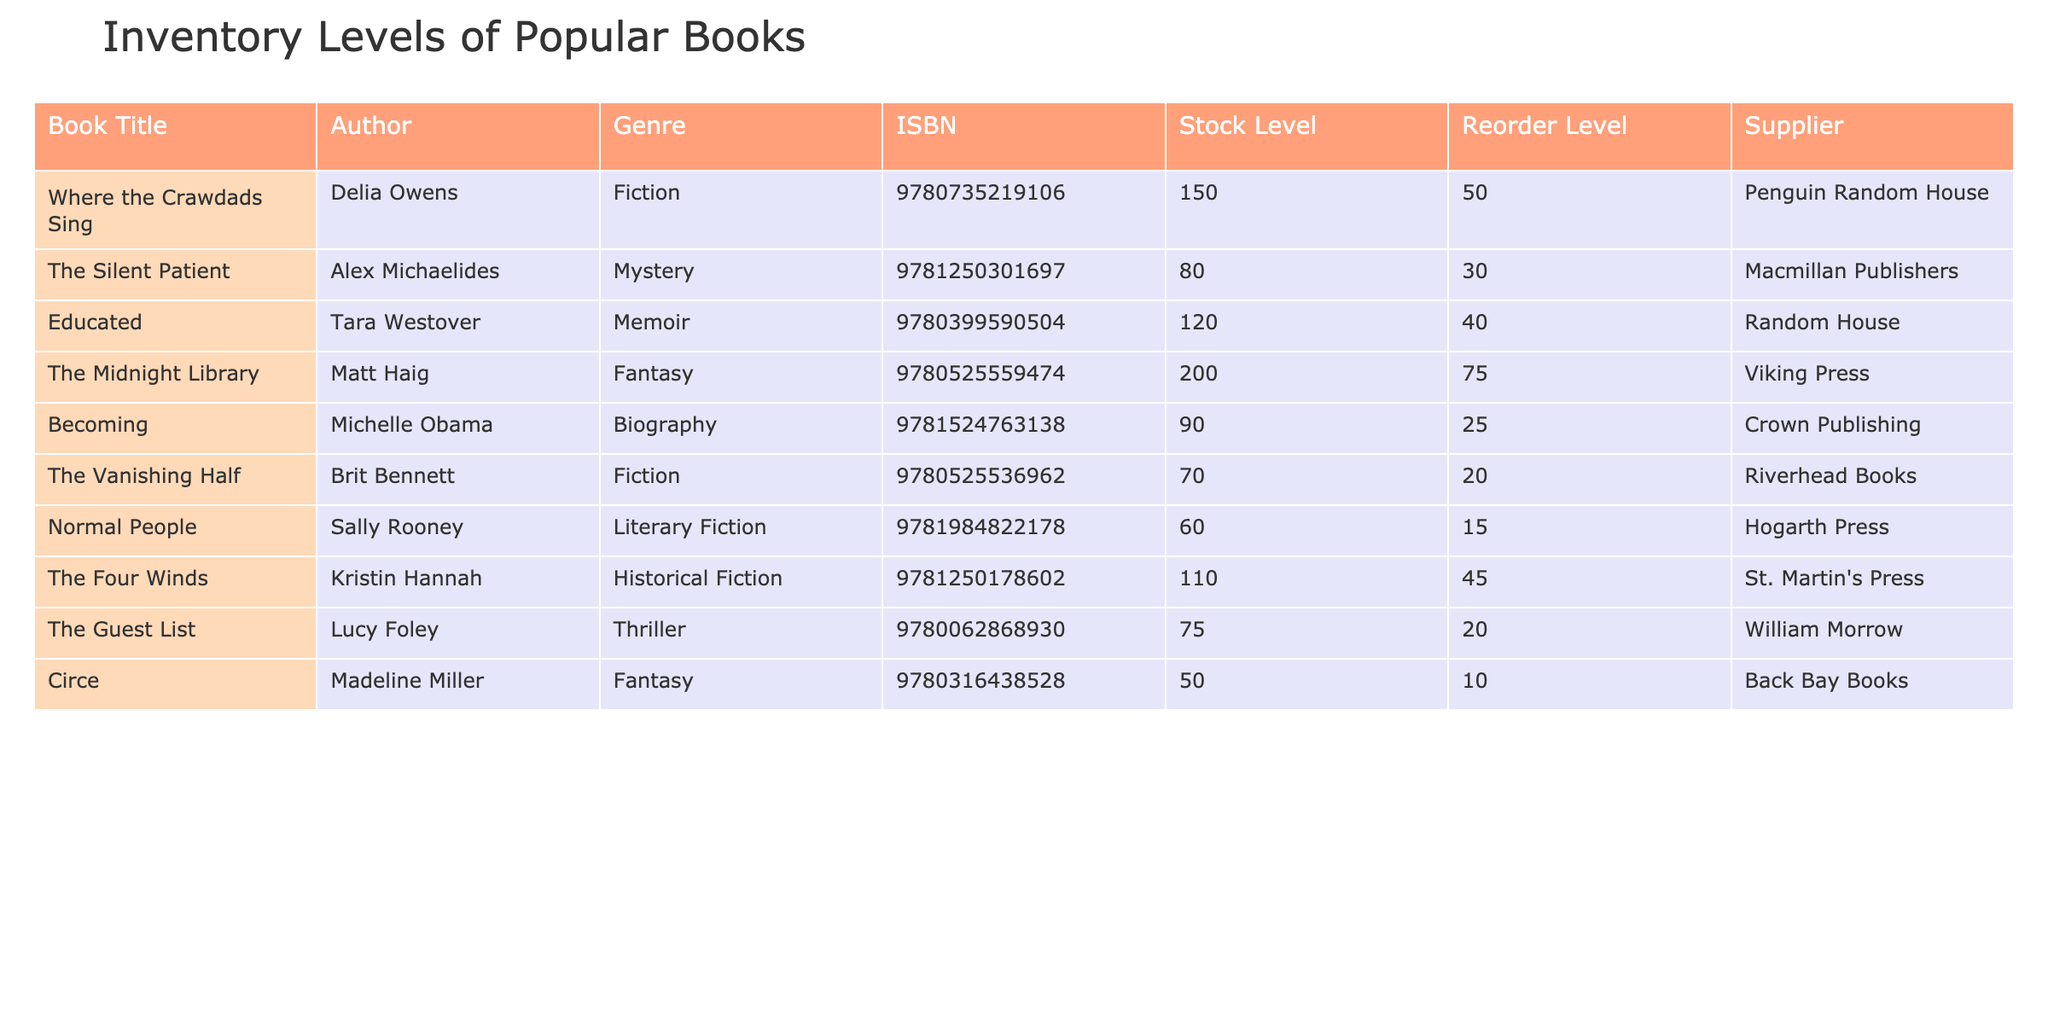What is the stock level of "The Silent Patient"? According to the table, the stock level of "The Silent Patient" is directly listed under the Stock Level column. Referring to the row associated with this book, we see the value is 80.
Answer: 80 Which book has the highest stock level? To determine which book has the highest stock level, we compare all stock levels listed. The values are 150, 80, 120, 200, 90, 70, 60, 110, 75, and 50. The maximum value is 200, corresponding to "The Midnight Library".
Answer: The Midnight Library Are there more than 100 copies of "Educated" in stock? The stock level of "Educated" is given as 120. Since 120 is greater than 100, we conclude that there are indeed more copies than 100.
Answer: Yes What is the average stock level of all books? First, we sum the stock levels: 150 + 80 + 120 + 200 + 90 + 70 + 60 + 110 + 75 + 50 = 1025. There are 10 books, so we divide 1025 by 10 to find the average, which is 102.5.
Answer: 102.5 Is the reorder level of "Circe" less than 15? The reorder level for "Circe" is listed as 10. Since 10 is less than 15, this statement is true.
Answer: Yes Which author has a book with a stock level below the reorder level? By reviewing the stock levels and their respective reorder levels, we identify "Normal People" by Sally Rooney with a stock level of 60 and reorder level of 15, and "The Vanishing Half" by Brit Bennett with a stock level of 70 and reorder level of 20. Both are above their reorder levels, but "Circe" by Madeline Miller has a stock level of 50 and definitely below its reorder level of 10.
Answer: Madeline Miller What is the difference in stock level between the book with the highest and lowest stock? The highest stock is 200 for "The Midnight Library", and the lowest stock is 50 for "Circe". The difference is calculated as 200 - 50 = 150.
Answer: 150 How many books have a stock level greater than their reorder level? We evaluate the list: "Where the Crawdads Sing" (150), "The Silent Patient" (80), "Educated" (120), "The Midnight Library" (200), "Becoming" (90), "The Vanishing Half" (70), "Normal People" (60), "The Four Winds" (110), "The Guest List" (75) all exceed their respective reorder levels. Only "Circe" (50) is the one below its reorder of 10. Thus, there are 9 books above their reorder levels.
Answer: 9 